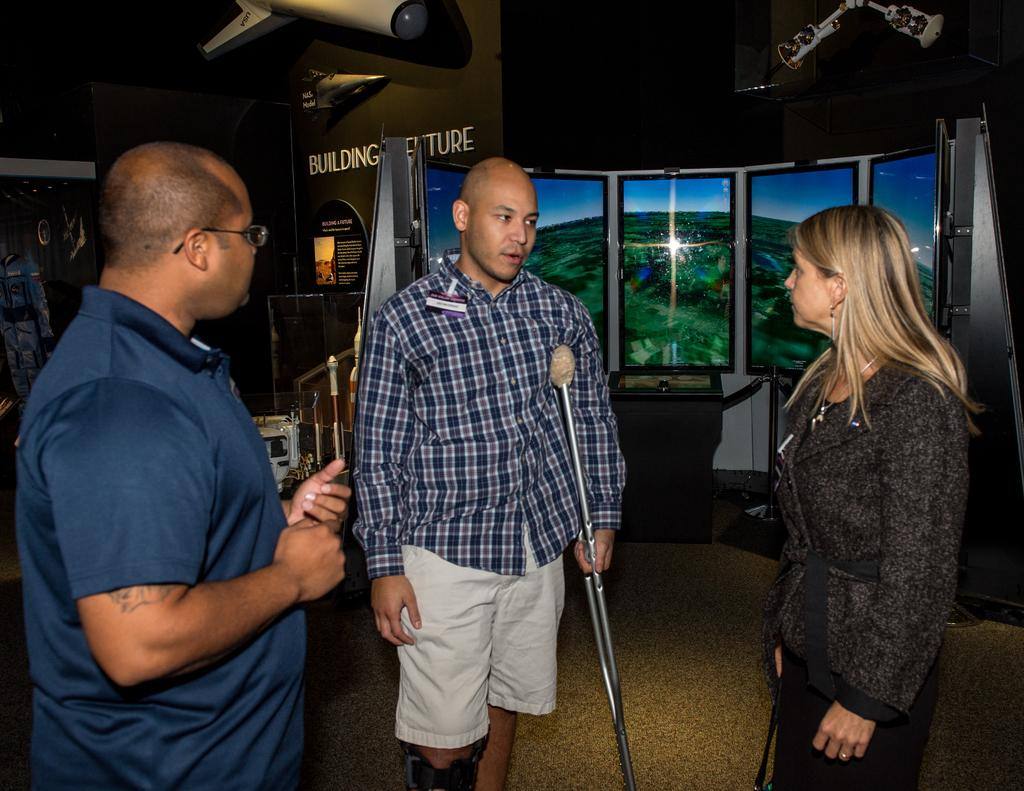How many people are present in the image? There are three people in the image: two men and a woman. What are the people doing in the image? The people are standing on the floor. What can be seen in the background of the image? There are windows and some objects visible in the background. What shape is the camera that the woman is holding in the image? There is no camera present in the image, so it is not possible to determine its shape. 